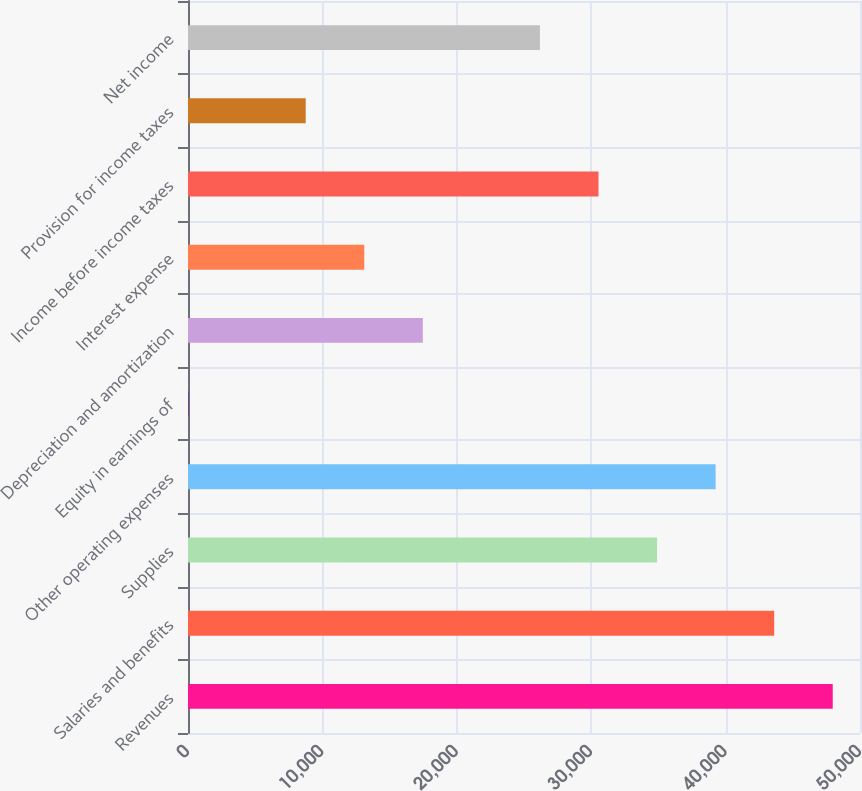<chart> <loc_0><loc_0><loc_500><loc_500><bar_chart><fcel>Revenues<fcel>Salaries and benefits<fcel>Supplies<fcel>Other operating expenses<fcel>Equity in earnings of<fcel>Depreciation and amortization<fcel>Interest expense<fcel>Income before income taxes<fcel>Provision for income taxes<fcel>Net income<nl><fcel>47970.9<fcel>43614<fcel>34900.2<fcel>39257.1<fcel>45<fcel>17472.6<fcel>13115.7<fcel>30543.3<fcel>8758.8<fcel>26186.4<nl></chart> 